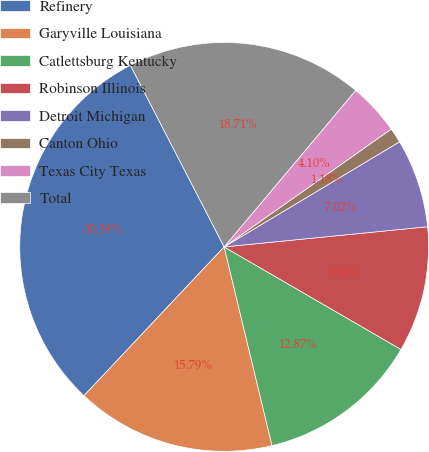<chart> <loc_0><loc_0><loc_500><loc_500><pie_chart><fcel>Refinery<fcel>Garyville Louisiana<fcel>Catlettsburg Kentucky<fcel>Robinson Illinois<fcel>Detroit Michigan<fcel>Canton Ohio<fcel>Texas City Texas<fcel>Total<nl><fcel>30.39%<fcel>15.79%<fcel>12.87%<fcel>9.94%<fcel>7.02%<fcel>1.18%<fcel>4.1%<fcel>18.71%<nl></chart> 